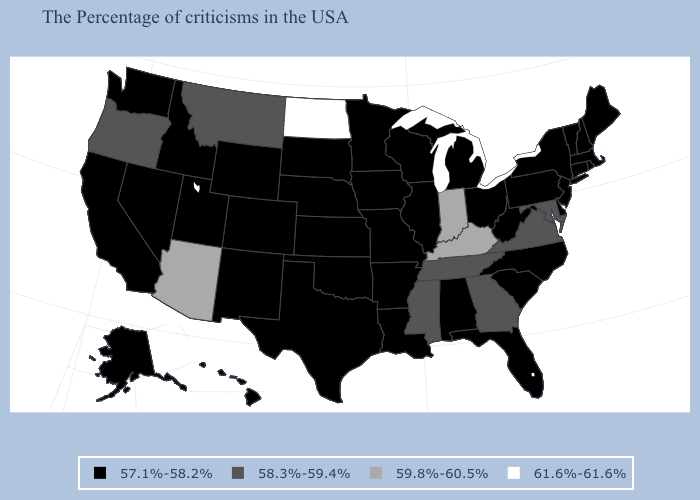Name the states that have a value in the range 57.1%-58.2%?
Short answer required. Maine, Massachusetts, Rhode Island, New Hampshire, Vermont, Connecticut, New York, New Jersey, Delaware, Pennsylvania, North Carolina, South Carolina, West Virginia, Ohio, Florida, Michigan, Alabama, Wisconsin, Illinois, Louisiana, Missouri, Arkansas, Minnesota, Iowa, Kansas, Nebraska, Oklahoma, Texas, South Dakota, Wyoming, Colorado, New Mexico, Utah, Idaho, Nevada, California, Washington, Alaska, Hawaii. What is the lowest value in the Northeast?
Short answer required. 57.1%-58.2%. Which states have the highest value in the USA?
Concise answer only. North Dakota. Name the states that have a value in the range 57.1%-58.2%?
Answer briefly. Maine, Massachusetts, Rhode Island, New Hampshire, Vermont, Connecticut, New York, New Jersey, Delaware, Pennsylvania, North Carolina, South Carolina, West Virginia, Ohio, Florida, Michigan, Alabama, Wisconsin, Illinois, Louisiana, Missouri, Arkansas, Minnesota, Iowa, Kansas, Nebraska, Oklahoma, Texas, South Dakota, Wyoming, Colorado, New Mexico, Utah, Idaho, Nevada, California, Washington, Alaska, Hawaii. Name the states that have a value in the range 61.6%-61.6%?
Give a very brief answer. North Dakota. What is the value of Illinois?
Answer briefly. 57.1%-58.2%. Which states have the lowest value in the USA?
Concise answer only. Maine, Massachusetts, Rhode Island, New Hampshire, Vermont, Connecticut, New York, New Jersey, Delaware, Pennsylvania, North Carolina, South Carolina, West Virginia, Ohio, Florida, Michigan, Alabama, Wisconsin, Illinois, Louisiana, Missouri, Arkansas, Minnesota, Iowa, Kansas, Nebraska, Oklahoma, Texas, South Dakota, Wyoming, Colorado, New Mexico, Utah, Idaho, Nevada, California, Washington, Alaska, Hawaii. Name the states that have a value in the range 57.1%-58.2%?
Short answer required. Maine, Massachusetts, Rhode Island, New Hampshire, Vermont, Connecticut, New York, New Jersey, Delaware, Pennsylvania, North Carolina, South Carolina, West Virginia, Ohio, Florida, Michigan, Alabama, Wisconsin, Illinois, Louisiana, Missouri, Arkansas, Minnesota, Iowa, Kansas, Nebraska, Oklahoma, Texas, South Dakota, Wyoming, Colorado, New Mexico, Utah, Idaho, Nevada, California, Washington, Alaska, Hawaii. Does New Hampshire have a lower value than Idaho?
Be succinct. No. What is the highest value in the South ?
Keep it brief. 59.8%-60.5%. What is the lowest value in the West?
Concise answer only. 57.1%-58.2%. What is the lowest value in states that border Massachusetts?
Answer briefly. 57.1%-58.2%. Name the states that have a value in the range 57.1%-58.2%?
Write a very short answer. Maine, Massachusetts, Rhode Island, New Hampshire, Vermont, Connecticut, New York, New Jersey, Delaware, Pennsylvania, North Carolina, South Carolina, West Virginia, Ohio, Florida, Michigan, Alabama, Wisconsin, Illinois, Louisiana, Missouri, Arkansas, Minnesota, Iowa, Kansas, Nebraska, Oklahoma, Texas, South Dakota, Wyoming, Colorado, New Mexico, Utah, Idaho, Nevada, California, Washington, Alaska, Hawaii. 